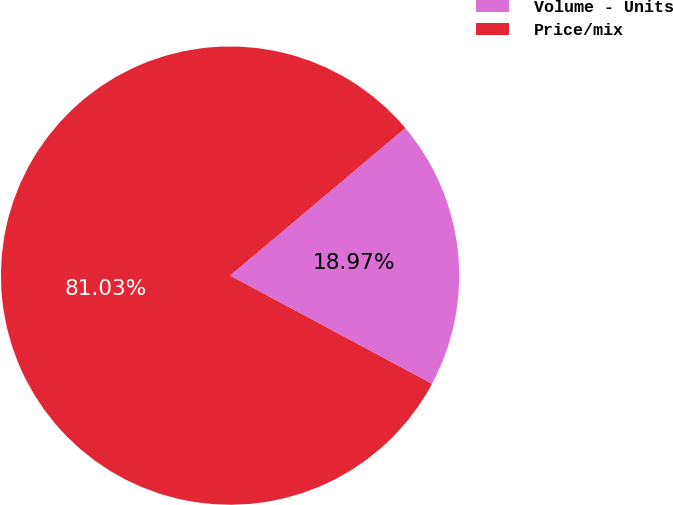Convert chart. <chart><loc_0><loc_0><loc_500><loc_500><pie_chart><fcel>Volume - Units<fcel>Price/mix<nl><fcel>18.97%<fcel>81.03%<nl></chart> 